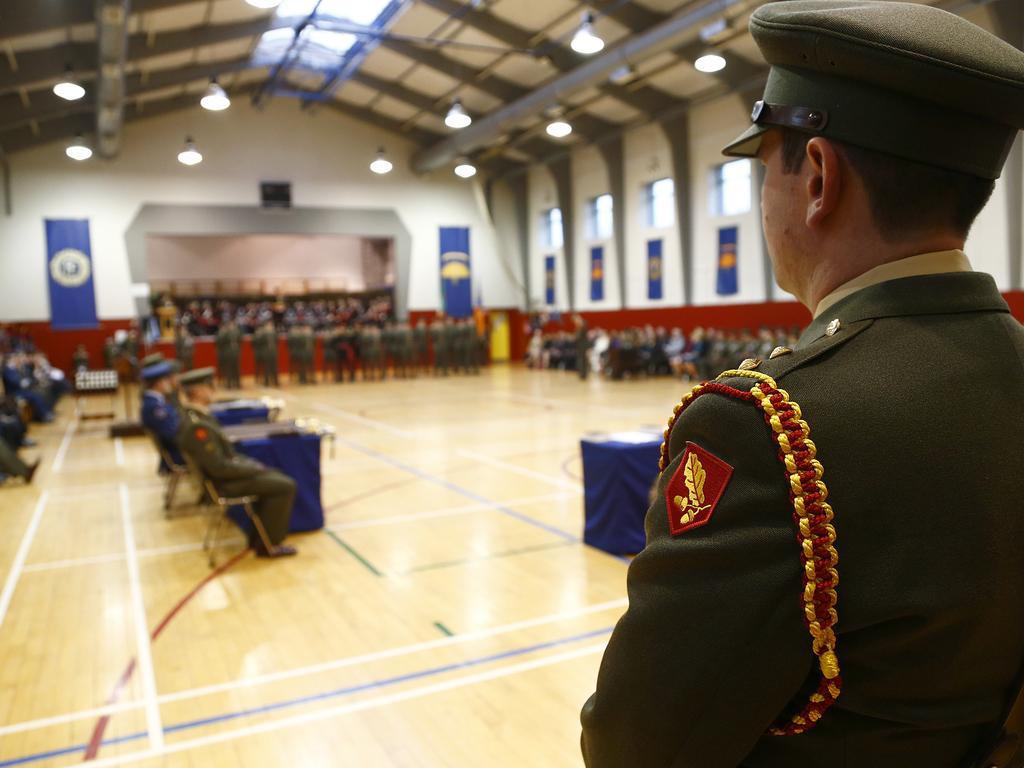Please provide a concise description of this image. There is hall with wooden floor and the rooftop with lamps. It seems Police meeting is going there. On the right side one police man standing and the left and right side people are sitting. In the background some people are standing and we can see blue color stickers on the wall. 